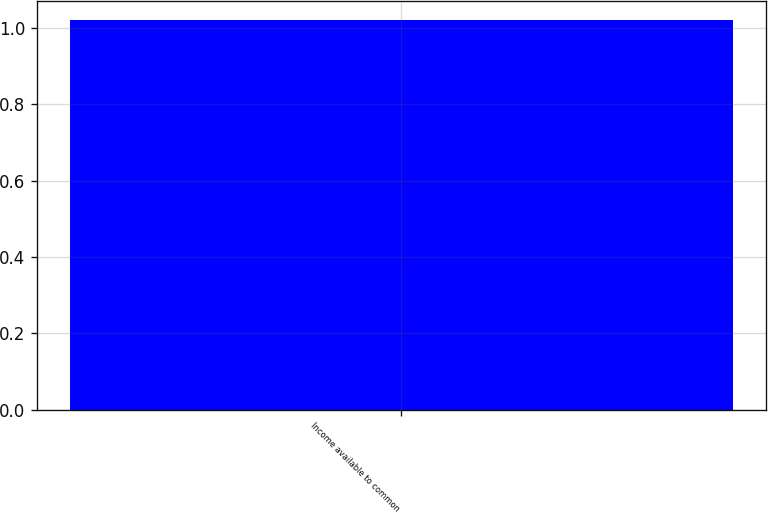Convert chart to OTSL. <chart><loc_0><loc_0><loc_500><loc_500><bar_chart><fcel>Income available to common<nl><fcel>1.02<nl></chart> 